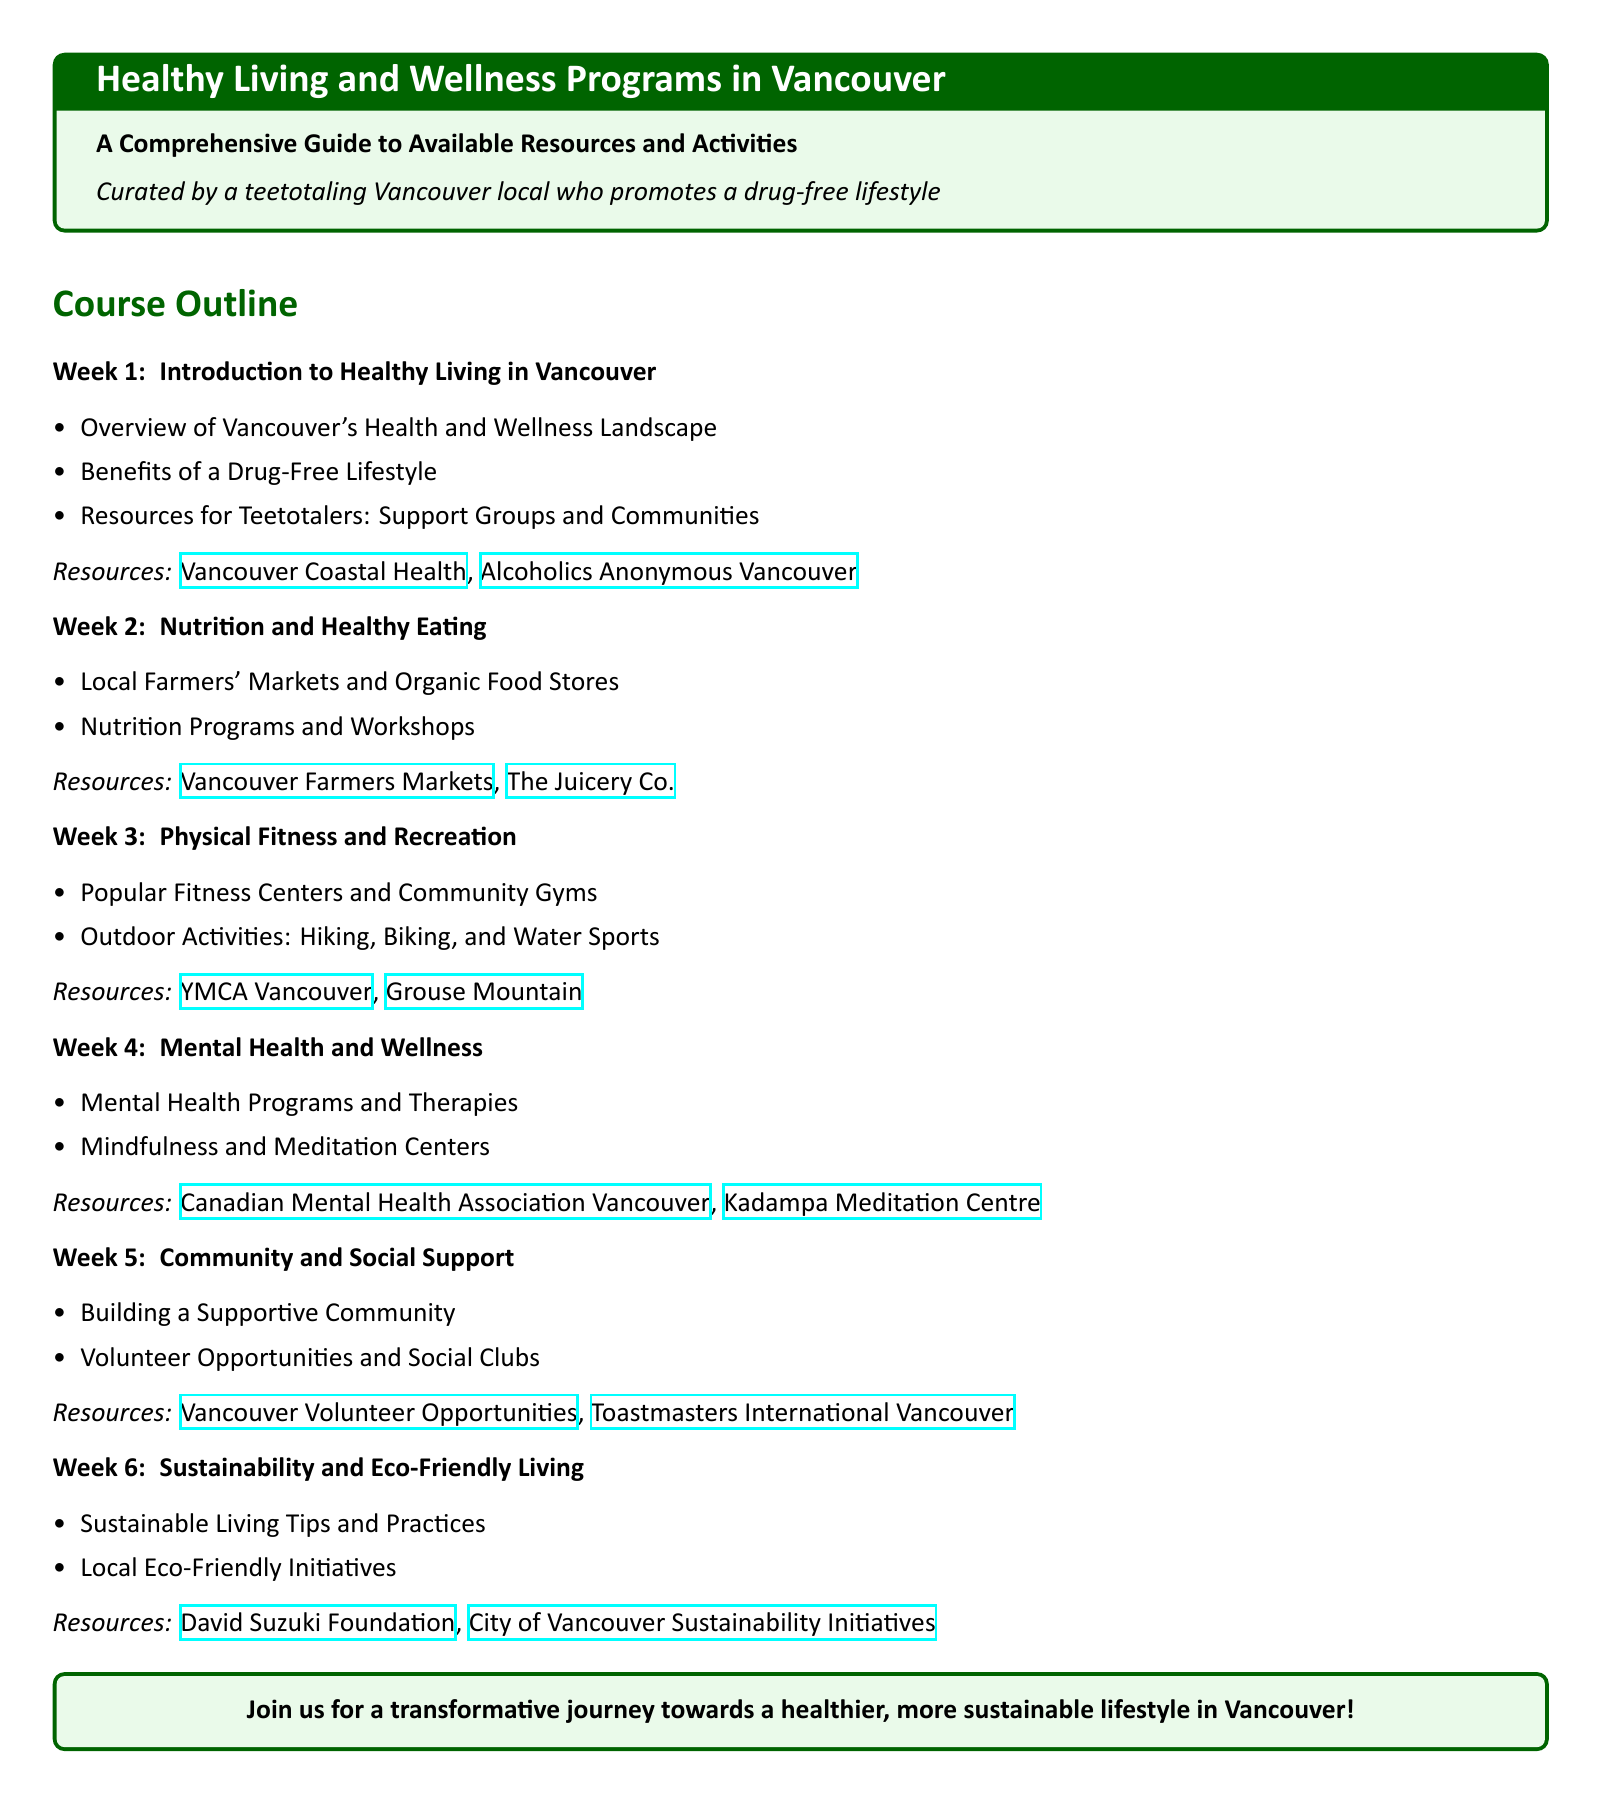What is the title of the document? The title is prominently displayed at the beginning of the document, which is "Healthy Living and Wellness Programs in Vancouver".
Answer: Healthy Living and Wellness Programs in Vancouver Who curated the guide? The document mentions that it was curated by a local who promotes a drug-free lifestyle.
Answer: A teetotaling Vancouver local What is discussed in Week 1? The topics taught in Week 1 include the overview of Vancouver's health landscape and the benefits of a drug-free lifestyle.
Answer: Introduction to Healthy Living in Vancouver How many weeks are covered in the syllabus? The syllabus contains a total of six weeks of topics.
Answer: Six What type of resources are recommended for nutrition? The document lists local farmers' markets and nutrition programs as resources for healthy eating.
Answer: Local Farmers' Markets and Organic Food Stores What is one mental health resource mentioned? In the document, one of the mental health resources provided is the Canadian Mental Health Association Vancouver.
Answer: Canadian Mental Health Association Vancouver Which outdoor activities are promoted? The syllabus mentions hiking, biking, and water sports as popular outdoor activities in Vancouver.
Answer: Hiking, Biking, and Water Sports What is the goal of the course? The document outlines a transformative journey towards a healthier and more sustainable lifestyle as the main goal of the course.
Answer: A healthier, more sustainable lifestyle 